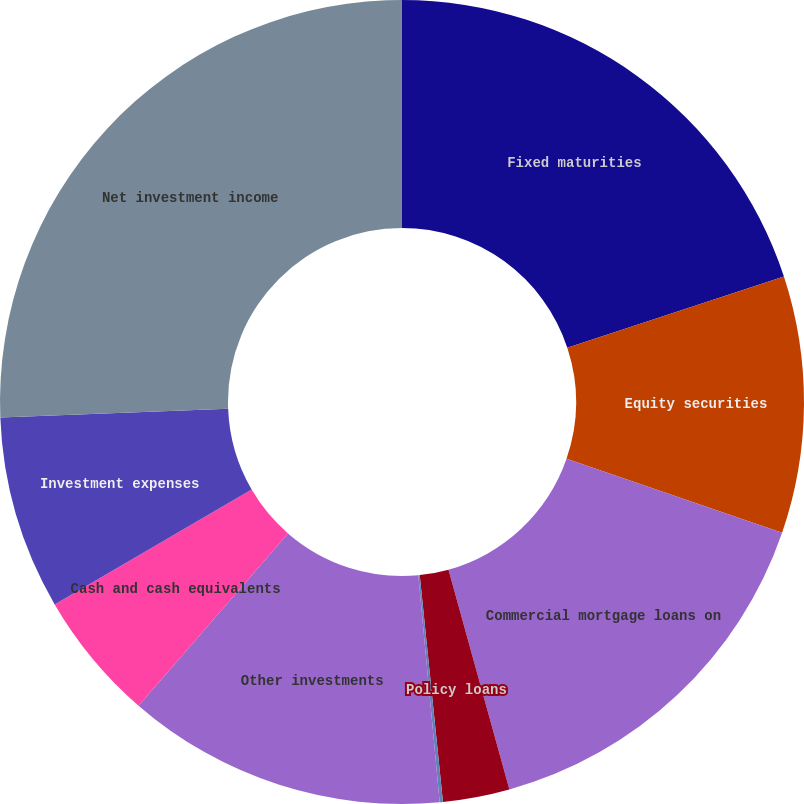<chart> <loc_0><loc_0><loc_500><loc_500><pie_chart><fcel>Fixed maturities<fcel>Equity securities<fcel>Commercial mortgage loans on<fcel>Policy loans<fcel>Short-term investments<fcel>Other investments<fcel>Cash and cash equivalents<fcel>Investment expenses<fcel>Net investment income<nl><fcel>19.95%<fcel>10.33%<fcel>15.42%<fcel>2.68%<fcel>0.13%<fcel>12.87%<fcel>5.23%<fcel>7.78%<fcel>25.62%<nl></chart> 